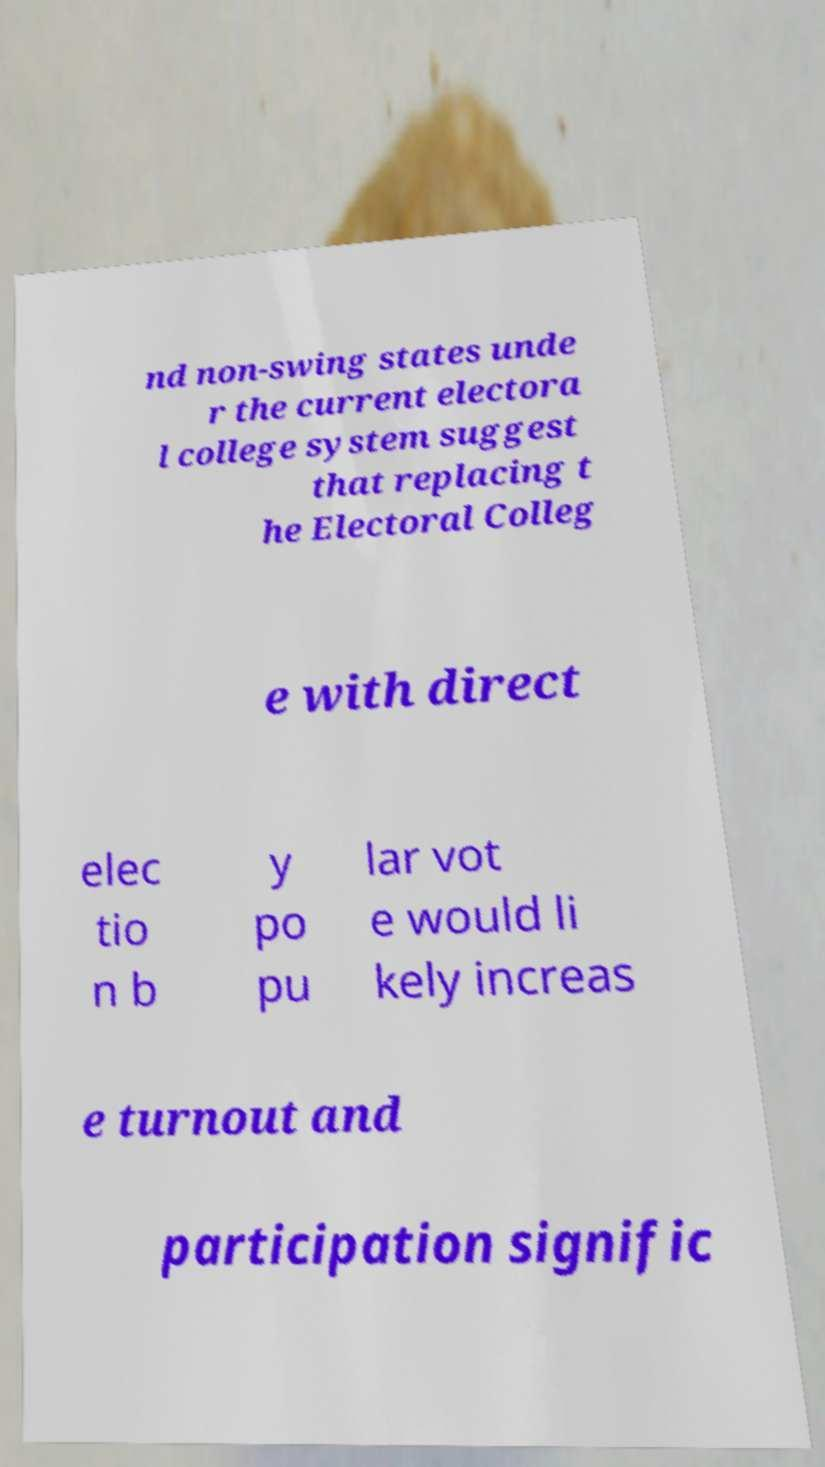What messages or text are displayed in this image? I need them in a readable, typed format. nd non-swing states unde r the current electora l college system suggest that replacing t he Electoral Colleg e with direct elec tio n b y po pu lar vot e would li kely increas e turnout and participation signific 